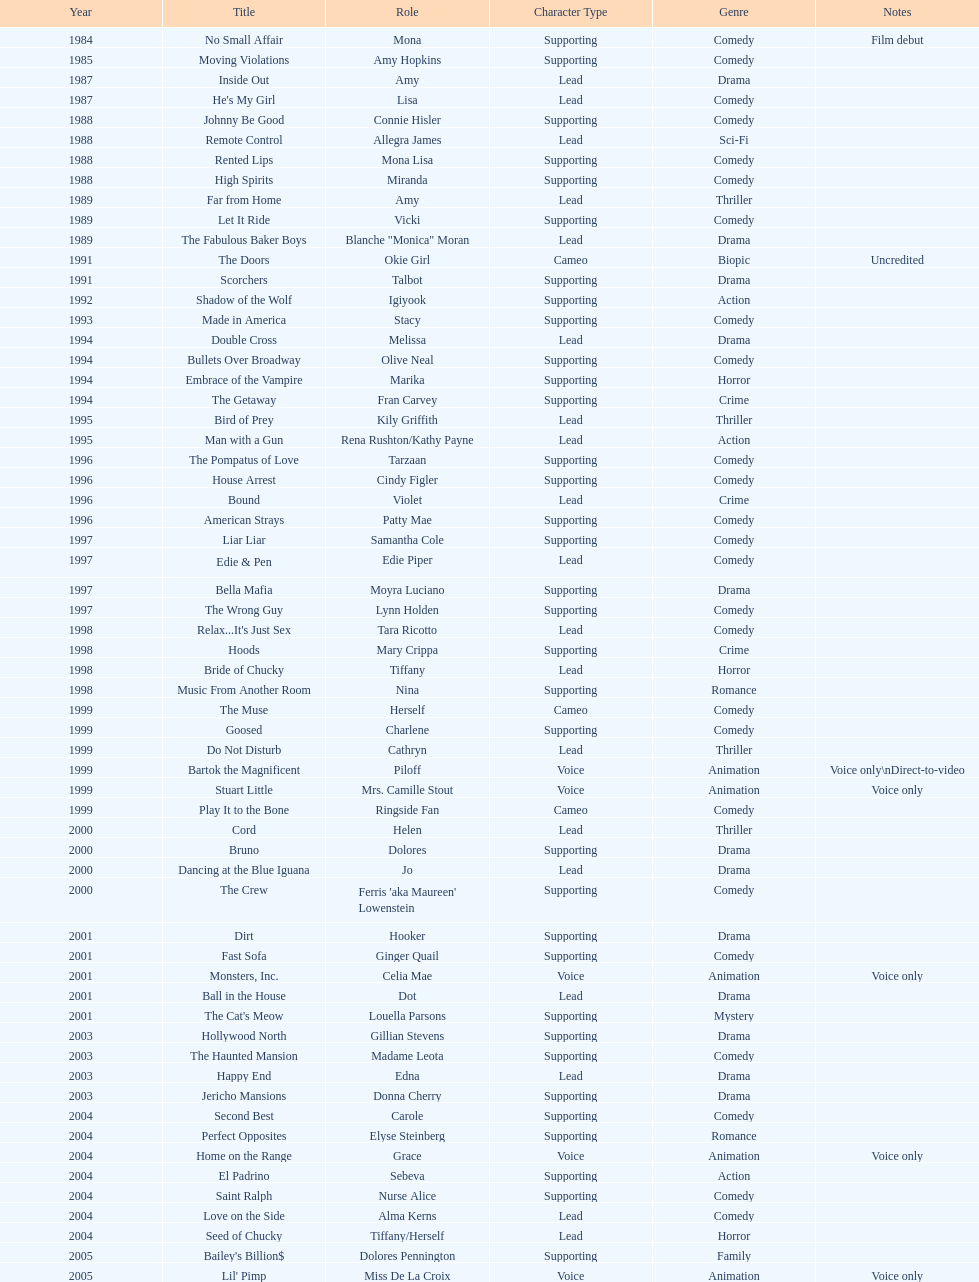Which year had the most credits? 2004. 